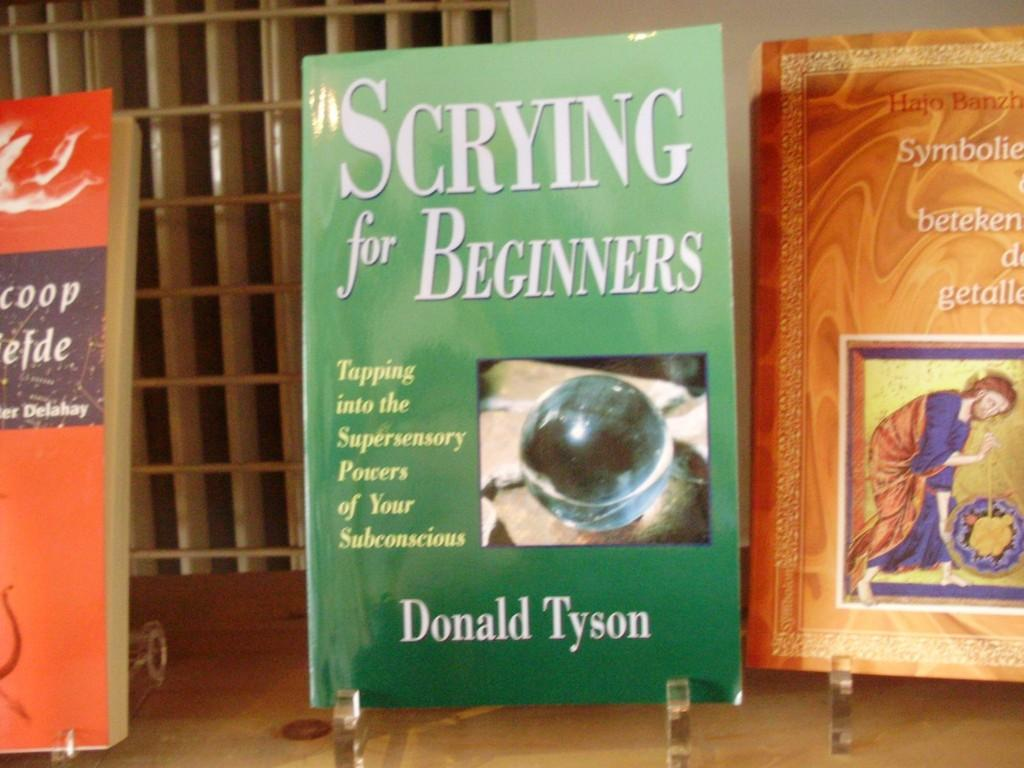<image>
Share a concise interpretation of the image provided. The books on display included "Scrying for Beginners" by Donald Tyson. 